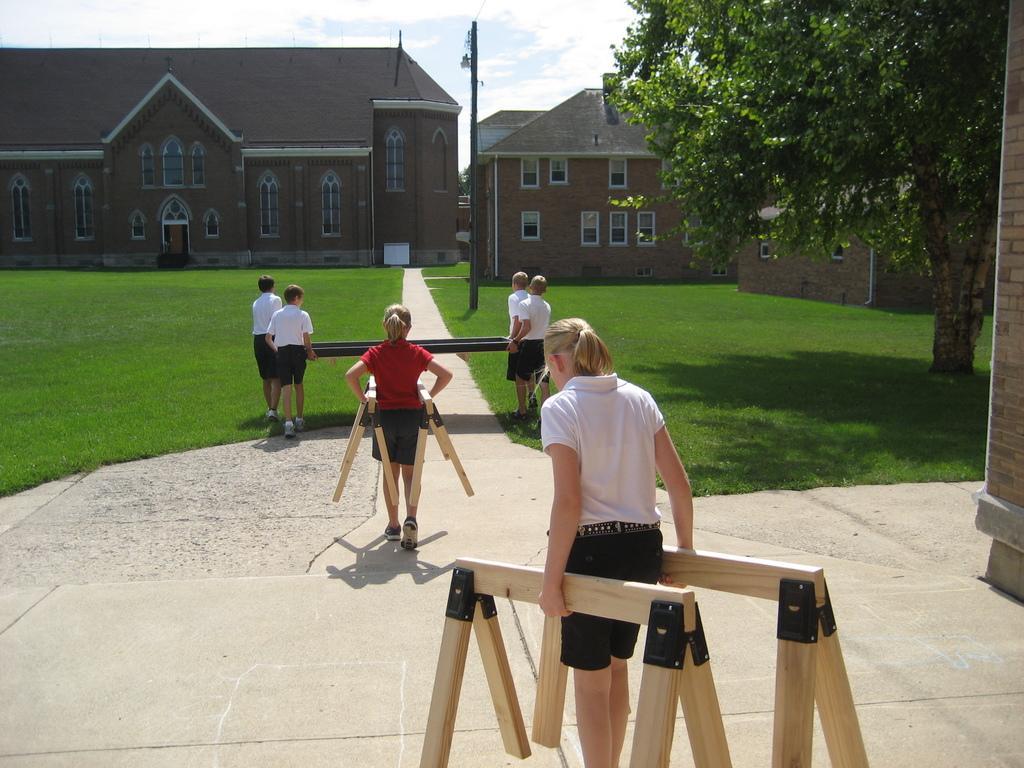Please provide a concise description of this image. In this image there are a few people holding a different types of wooden structures in their hands, there is a path. On the left and right side of the path there is a grass and there are trees, poles and in the background there are buildings and the sky. 